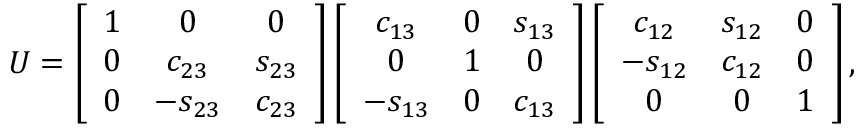<formula> <loc_0><loc_0><loc_500><loc_500>U = \left [ \begin{array} { c c c } { 1 } & { 0 } & { 0 } \\ { 0 } & { { c _ { 2 3 } } } & { { s _ { 2 3 } } } \\ { 0 } & { { - s _ { 2 3 } } } & { { c _ { 2 3 } } } \end{array} \right ] \left [ \begin{array} { c c c } { { c _ { 1 3 } } } & { 0 } & { { s _ { 1 3 } } } \\ { 0 } & { 1 } & { 0 } \\ { { - s _ { 1 3 } } } & { 0 } & { { c _ { 1 3 } } } \end{array} \right ] \left [ \begin{array} { c c c } { { c _ { 1 2 } } } & { { s _ { 1 2 } } } & { 0 } \\ { { - s _ { 1 2 } } } & { { c _ { 1 2 } } } & { 0 } \\ { 0 } & { 0 } & { 1 } \end{array} \right ] ,</formula> 